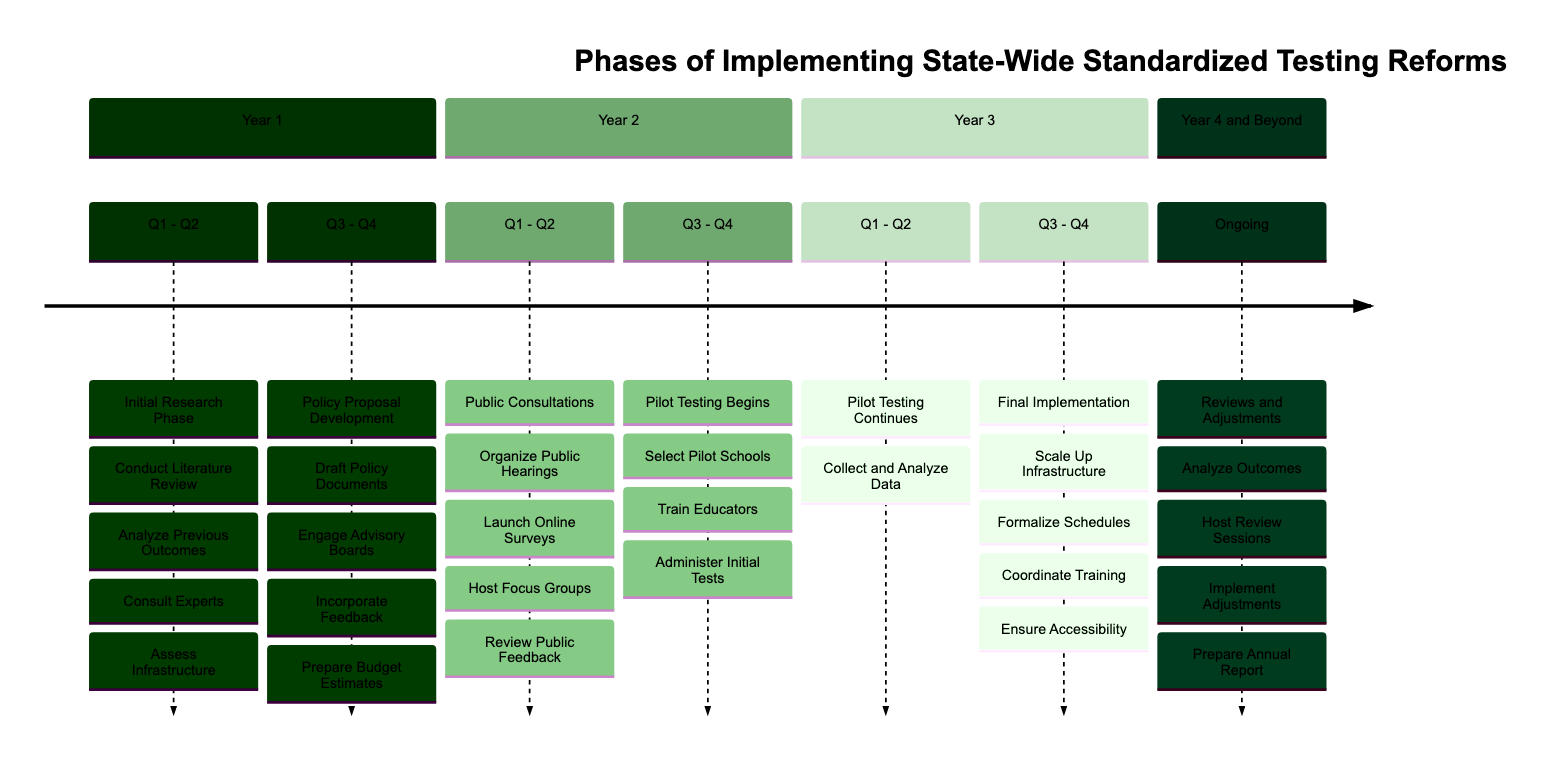What is the first phase in the diagram? The first phase listed in the timeline is "Initial Research Phase," which appears at the beginning of Year 1.
Answer: Initial Research Phase How long does the Public Consultations phase last? The Public Consultations phase starts in Q1 and ends in Q2 of Year 2, making it a duration of two quarters.
Answer: Q1 - Q2, Year 2 What activities are included in the final implementation phase? The activities mentioned for the Final Implementation phase include scaling up infrastructure, formalizing schedules, coordinating training, and ensuring accessibility.
Answer: Scale Up Testing Infrastructure, Formalize Testing Schedules, Coordinate State-Wide Educator Training, Ensure Accessibility Accommodations What follows after the Pilot Testing phase? After the Pilot Testing phase, which spans from Q3 of Year 2 to Q4 of Year 3, the next phase is Final Implementation.
Answer: Final Implementation How many total phases are there in the diagram? There are six distinct phases listed in the diagram, ranging from Initial Research Phase to Subsequent Reviews and Adjustments.
Answer: 6 What are the activities during the Initial Research Phase? The activities listed under the Initial Research Phase include conducting literature reviews, analyzing previous outcomes, consulting experts, and assessing infrastructure.
Answer: Conduct Literature Review, Analyze Previous Outcomes, Consult with Education Policy Experts, Assess Technology Infrastructure for Online Testing In which year does the Pilot Testing phase start? The Pilot Testing phase begins in Q3 of Year 2.
Answer: Q3, Year 2 What is the last phase mentioned in the timeline? The last phase mentioned in the timeline is "Subsequent Reviews and Adjustments," which is ongoing after Year 4.
Answer: Subsequent Reviews and Adjustments 